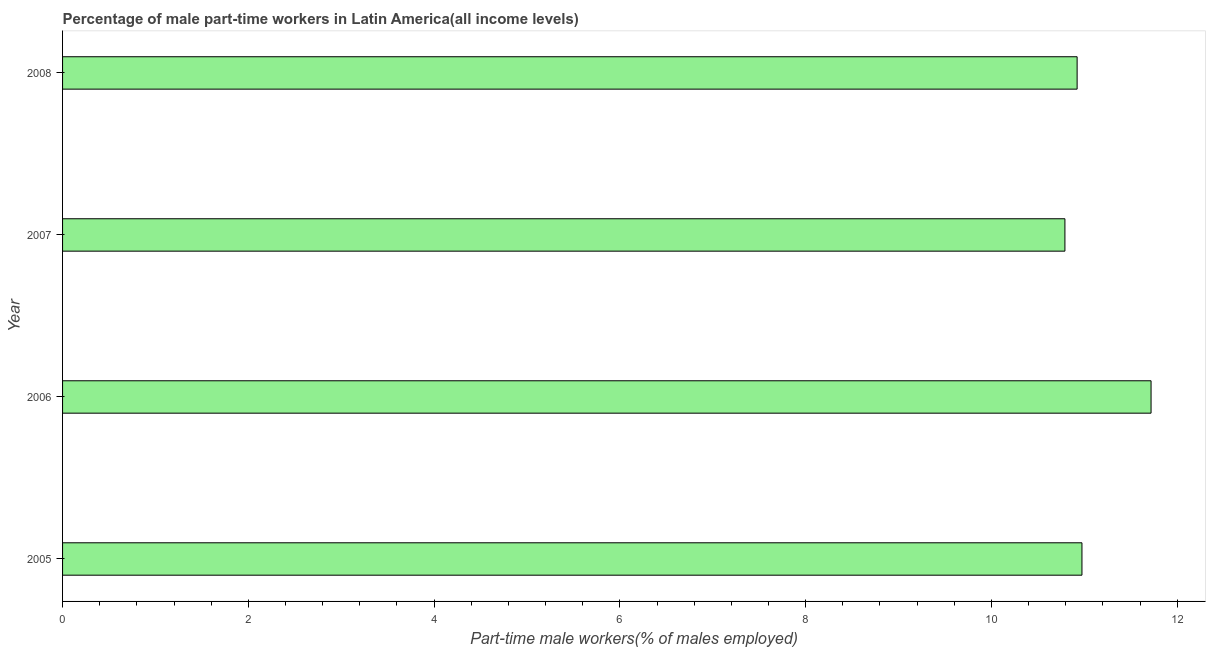Does the graph contain any zero values?
Make the answer very short. No. Does the graph contain grids?
Offer a terse response. No. What is the title of the graph?
Make the answer very short. Percentage of male part-time workers in Latin America(all income levels). What is the label or title of the X-axis?
Ensure brevity in your answer.  Part-time male workers(% of males employed). What is the percentage of part-time male workers in 2006?
Provide a short and direct response. 11.72. Across all years, what is the maximum percentage of part-time male workers?
Offer a very short reply. 11.72. Across all years, what is the minimum percentage of part-time male workers?
Your response must be concise. 10.79. In which year was the percentage of part-time male workers maximum?
Your answer should be compact. 2006. What is the sum of the percentage of part-time male workers?
Your answer should be very brief. 44.41. What is the difference between the percentage of part-time male workers in 2005 and 2008?
Your answer should be very brief. 0.05. What is the average percentage of part-time male workers per year?
Provide a succinct answer. 11.1. What is the median percentage of part-time male workers?
Ensure brevity in your answer.  10.95. In how many years, is the percentage of part-time male workers greater than 10.8 %?
Provide a succinct answer. 3. Do a majority of the years between 2006 and 2005 (inclusive) have percentage of part-time male workers greater than 4.8 %?
Give a very brief answer. No. Is the difference between the percentage of part-time male workers in 2006 and 2008 greater than the difference between any two years?
Your answer should be very brief. No. What is the difference between the highest and the second highest percentage of part-time male workers?
Provide a succinct answer. 0.74. Is the sum of the percentage of part-time male workers in 2006 and 2007 greater than the maximum percentage of part-time male workers across all years?
Offer a terse response. Yes. How many bars are there?
Give a very brief answer. 4. How many years are there in the graph?
Provide a succinct answer. 4. Are the values on the major ticks of X-axis written in scientific E-notation?
Give a very brief answer. No. What is the Part-time male workers(% of males employed) in 2005?
Offer a terse response. 10.97. What is the Part-time male workers(% of males employed) of 2006?
Make the answer very short. 11.72. What is the Part-time male workers(% of males employed) in 2007?
Give a very brief answer. 10.79. What is the Part-time male workers(% of males employed) in 2008?
Your answer should be compact. 10.92. What is the difference between the Part-time male workers(% of males employed) in 2005 and 2006?
Provide a succinct answer. -0.74. What is the difference between the Part-time male workers(% of males employed) in 2005 and 2007?
Keep it short and to the point. 0.18. What is the difference between the Part-time male workers(% of males employed) in 2005 and 2008?
Ensure brevity in your answer.  0.05. What is the difference between the Part-time male workers(% of males employed) in 2006 and 2007?
Your answer should be very brief. 0.93. What is the difference between the Part-time male workers(% of males employed) in 2006 and 2008?
Provide a short and direct response. 0.8. What is the difference between the Part-time male workers(% of males employed) in 2007 and 2008?
Keep it short and to the point. -0.13. What is the ratio of the Part-time male workers(% of males employed) in 2005 to that in 2006?
Provide a short and direct response. 0.94. What is the ratio of the Part-time male workers(% of males employed) in 2005 to that in 2008?
Ensure brevity in your answer.  1. What is the ratio of the Part-time male workers(% of males employed) in 2006 to that in 2007?
Your answer should be very brief. 1.09. What is the ratio of the Part-time male workers(% of males employed) in 2006 to that in 2008?
Offer a terse response. 1.07. What is the ratio of the Part-time male workers(% of males employed) in 2007 to that in 2008?
Make the answer very short. 0.99. 